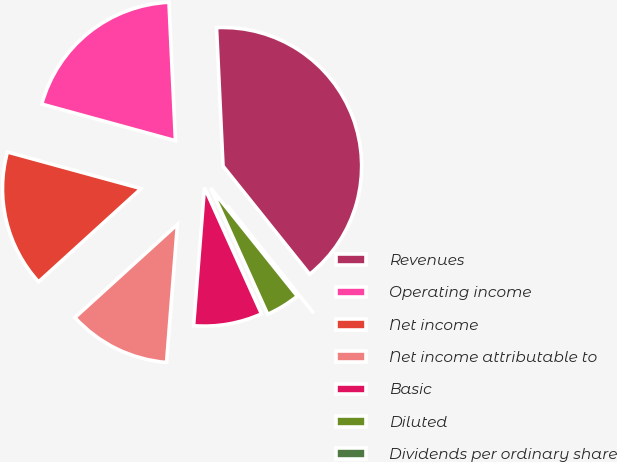Convert chart. <chart><loc_0><loc_0><loc_500><loc_500><pie_chart><fcel>Revenues<fcel>Operating income<fcel>Net income<fcel>Net income attributable to<fcel>Basic<fcel>Diluted<fcel>Dividends per ordinary share<nl><fcel>40.0%<fcel>20.0%<fcel>16.0%<fcel>12.0%<fcel>8.0%<fcel>4.0%<fcel>0.0%<nl></chart> 